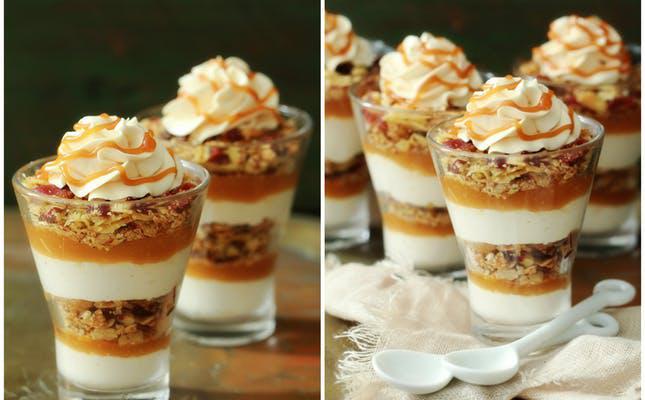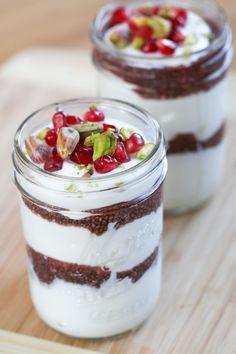The first image is the image on the left, the second image is the image on the right. Considering the images on both sides, is "The right image shows exactly two virtually identical trifle desserts." valid? Answer yes or no. Yes. The first image is the image on the left, the second image is the image on the right. Considering the images on both sides, is "There is at least one cherry with a stem in the image on the right." valid? Answer yes or no. No. 